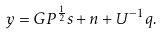Convert formula to latex. <formula><loc_0><loc_0><loc_500><loc_500>y = G P ^ { \frac { 1 } { 2 } } { s } + { n } + U ^ { - 1 } q .</formula> 